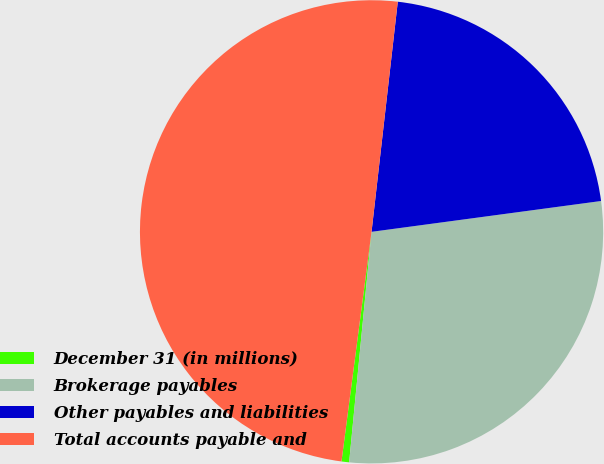<chart> <loc_0><loc_0><loc_500><loc_500><pie_chart><fcel>December 31 (in millions)<fcel>Brokerage payables<fcel>Other payables and liabilities<fcel>Total accounts payable and<nl><fcel>0.53%<fcel>28.67%<fcel>21.07%<fcel>49.74%<nl></chart> 